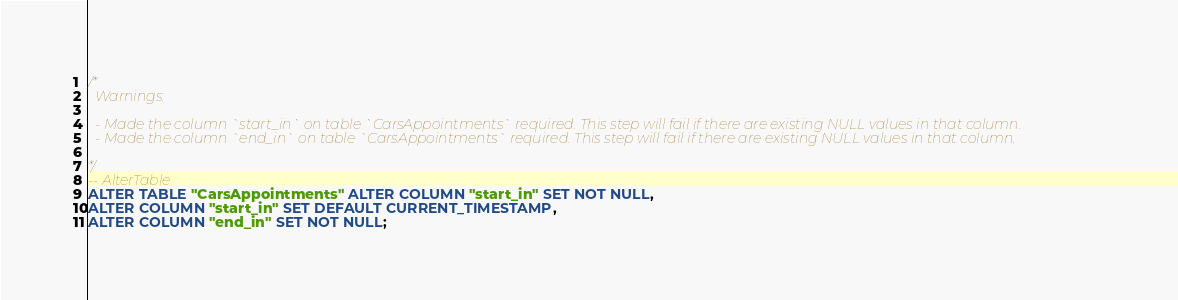<code> <loc_0><loc_0><loc_500><loc_500><_SQL_>/*
  Warnings:

  - Made the column `start_in` on table `CarsAppointments` required. This step will fail if there are existing NULL values in that column.
  - Made the column `end_in` on table `CarsAppointments` required. This step will fail if there are existing NULL values in that column.

*/
-- AlterTable
ALTER TABLE "CarsAppointments" ALTER COLUMN "start_in" SET NOT NULL,
ALTER COLUMN "start_in" SET DEFAULT CURRENT_TIMESTAMP,
ALTER COLUMN "end_in" SET NOT NULL;
</code> 